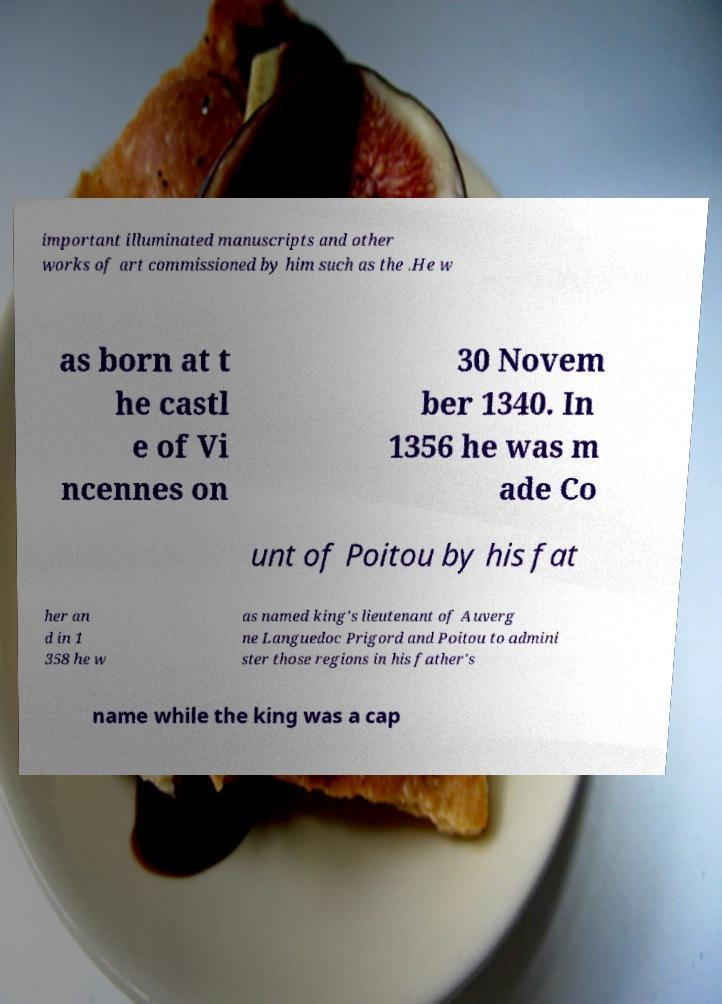For documentation purposes, I need the text within this image transcribed. Could you provide that? important illuminated manuscripts and other works of art commissioned by him such as the .He w as born at t he castl e of Vi ncennes on 30 Novem ber 1340. In 1356 he was m ade Co unt of Poitou by his fat her an d in 1 358 he w as named king's lieutenant of Auverg ne Languedoc Prigord and Poitou to admini ster those regions in his father's name while the king was a cap 